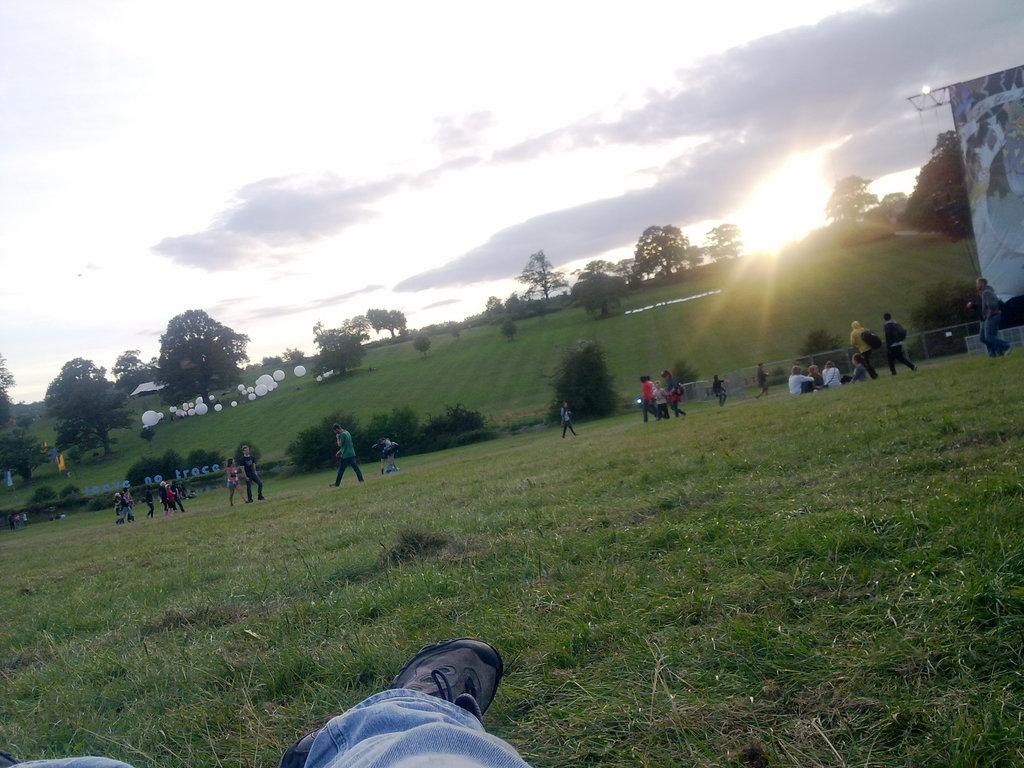What is the main subject of the image? There is a person in the image. Can you describe the setting in the background of the image? There is a group of persons standing on the grass, and there are trees, a banner, boards, balloons, and the sky visible in the background. How many people are in the background of the image? There is a group of persons in the background of the image. What might be the purpose of the banner in the background? The banner in the background might be used for advertising or conveying a message. What time of day is it in the image, based on the hour? The provided facts do not mention the time of day or any specific hour, so it cannot be determined from the image. What type of knowledge is being shared among the group of persons in the image? There is no indication of any knowledge being shared among the group of persons in the image. Is there a bed visible in the image? No, there is no bed present in the image. 